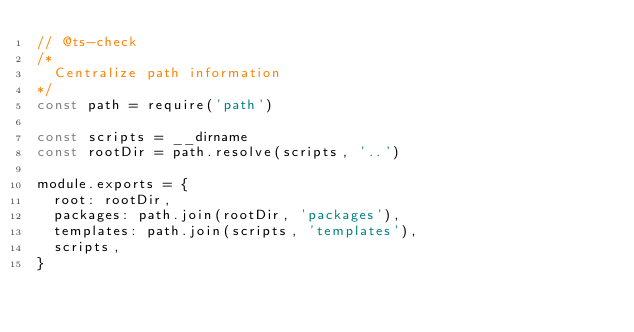Convert code to text. <code><loc_0><loc_0><loc_500><loc_500><_JavaScript_>// @ts-check
/*
  Centralize path information
*/
const path = require('path')

const scripts = __dirname
const rootDir = path.resolve(scripts, '..')

module.exports = {
  root: rootDir,
  packages: path.join(rootDir, 'packages'),
  templates: path.join(scripts, 'templates'),
  scripts,
}
</code> 